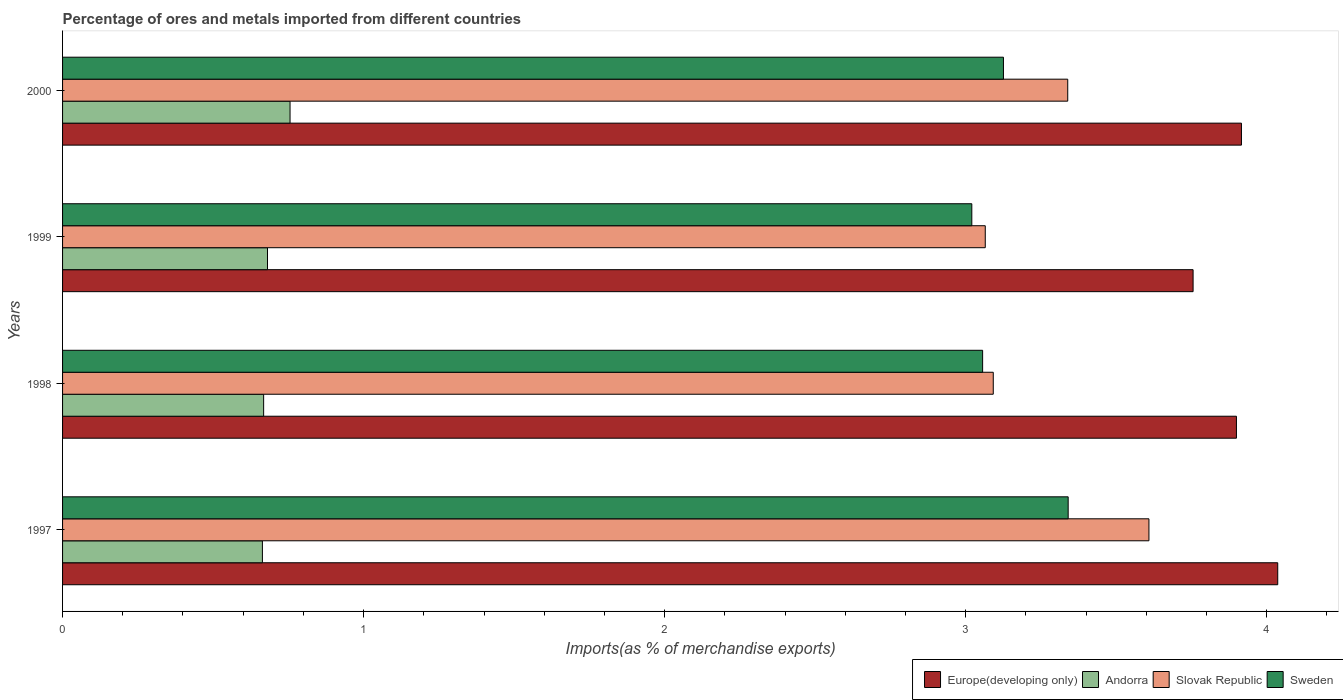How many different coloured bars are there?
Ensure brevity in your answer.  4. How many groups of bars are there?
Provide a succinct answer. 4. How many bars are there on the 1st tick from the bottom?
Provide a succinct answer. 4. What is the label of the 2nd group of bars from the top?
Offer a very short reply. 1999. What is the percentage of imports to different countries in Sweden in 2000?
Make the answer very short. 3.13. Across all years, what is the maximum percentage of imports to different countries in Sweden?
Provide a short and direct response. 3.34. Across all years, what is the minimum percentage of imports to different countries in Sweden?
Ensure brevity in your answer.  3.02. In which year was the percentage of imports to different countries in Sweden maximum?
Your answer should be compact. 1997. In which year was the percentage of imports to different countries in Europe(developing only) minimum?
Provide a succinct answer. 1999. What is the total percentage of imports to different countries in Andorra in the graph?
Make the answer very short. 2.77. What is the difference between the percentage of imports to different countries in Sweden in 1997 and that in 2000?
Your answer should be compact. 0.21. What is the difference between the percentage of imports to different countries in Slovak Republic in 2000 and the percentage of imports to different countries in Andorra in 1998?
Offer a very short reply. 2.67. What is the average percentage of imports to different countries in Europe(developing only) per year?
Make the answer very short. 3.9. In the year 2000, what is the difference between the percentage of imports to different countries in Slovak Republic and percentage of imports to different countries in Andorra?
Offer a terse response. 2.58. In how many years, is the percentage of imports to different countries in Europe(developing only) greater than 4 %?
Offer a very short reply. 1. What is the ratio of the percentage of imports to different countries in Andorra in 1997 to that in 2000?
Your response must be concise. 0.88. Is the percentage of imports to different countries in Andorra in 1998 less than that in 2000?
Your answer should be compact. Yes. Is the difference between the percentage of imports to different countries in Slovak Republic in 1998 and 2000 greater than the difference between the percentage of imports to different countries in Andorra in 1998 and 2000?
Your answer should be compact. No. What is the difference between the highest and the second highest percentage of imports to different countries in Europe(developing only)?
Your response must be concise. 0.12. What is the difference between the highest and the lowest percentage of imports to different countries in Slovak Republic?
Your response must be concise. 0.54. In how many years, is the percentage of imports to different countries in Slovak Republic greater than the average percentage of imports to different countries in Slovak Republic taken over all years?
Provide a succinct answer. 2. What does the 3rd bar from the top in 1997 represents?
Provide a succinct answer. Andorra. What does the 1st bar from the bottom in 1997 represents?
Ensure brevity in your answer.  Europe(developing only). How many years are there in the graph?
Ensure brevity in your answer.  4. Does the graph contain any zero values?
Ensure brevity in your answer.  No. Where does the legend appear in the graph?
Offer a terse response. Bottom right. How are the legend labels stacked?
Provide a short and direct response. Horizontal. What is the title of the graph?
Give a very brief answer. Percentage of ores and metals imported from different countries. Does "Cabo Verde" appear as one of the legend labels in the graph?
Provide a short and direct response. No. What is the label or title of the X-axis?
Your answer should be very brief. Imports(as % of merchandise exports). What is the Imports(as % of merchandise exports) of Europe(developing only) in 1997?
Make the answer very short. 4.04. What is the Imports(as % of merchandise exports) in Andorra in 1997?
Make the answer very short. 0.66. What is the Imports(as % of merchandise exports) of Slovak Republic in 1997?
Provide a short and direct response. 3.61. What is the Imports(as % of merchandise exports) in Sweden in 1997?
Your answer should be very brief. 3.34. What is the Imports(as % of merchandise exports) of Europe(developing only) in 1998?
Your answer should be very brief. 3.9. What is the Imports(as % of merchandise exports) of Andorra in 1998?
Make the answer very short. 0.67. What is the Imports(as % of merchandise exports) of Slovak Republic in 1998?
Your answer should be very brief. 3.09. What is the Imports(as % of merchandise exports) in Sweden in 1998?
Your response must be concise. 3.06. What is the Imports(as % of merchandise exports) in Europe(developing only) in 1999?
Offer a terse response. 3.76. What is the Imports(as % of merchandise exports) in Andorra in 1999?
Your response must be concise. 0.68. What is the Imports(as % of merchandise exports) of Slovak Republic in 1999?
Your response must be concise. 3.07. What is the Imports(as % of merchandise exports) in Sweden in 1999?
Offer a very short reply. 3.02. What is the Imports(as % of merchandise exports) in Europe(developing only) in 2000?
Offer a very short reply. 3.92. What is the Imports(as % of merchandise exports) of Andorra in 2000?
Provide a short and direct response. 0.76. What is the Imports(as % of merchandise exports) in Slovak Republic in 2000?
Your answer should be compact. 3.34. What is the Imports(as % of merchandise exports) of Sweden in 2000?
Your answer should be very brief. 3.13. Across all years, what is the maximum Imports(as % of merchandise exports) of Europe(developing only)?
Give a very brief answer. 4.04. Across all years, what is the maximum Imports(as % of merchandise exports) in Andorra?
Keep it short and to the point. 0.76. Across all years, what is the maximum Imports(as % of merchandise exports) of Slovak Republic?
Ensure brevity in your answer.  3.61. Across all years, what is the maximum Imports(as % of merchandise exports) in Sweden?
Keep it short and to the point. 3.34. Across all years, what is the minimum Imports(as % of merchandise exports) of Europe(developing only)?
Your answer should be compact. 3.76. Across all years, what is the minimum Imports(as % of merchandise exports) of Andorra?
Ensure brevity in your answer.  0.66. Across all years, what is the minimum Imports(as % of merchandise exports) in Slovak Republic?
Make the answer very short. 3.07. Across all years, what is the minimum Imports(as % of merchandise exports) of Sweden?
Your response must be concise. 3.02. What is the total Imports(as % of merchandise exports) of Europe(developing only) in the graph?
Your response must be concise. 15.61. What is the total Imports(as % of merchandise exports) in Andorra in the graph?
Offer a very short reply. 2.77. What is the total Imports(as % of merchandise exports) of Slovak Republic in the graph?
Offer a very short reply. 13.1. What is the total Imports(as % of merchandise exports) in Sweden in the graph?
Offer a terse response. 12.54. What is the difference between the Imports(as % of merchandise exports) of Europe(developing only) in 1997 and that in 1998?
Provide a short and direct response. 0.14. What is the difference between the Imports(as % of merchandise exports) in Andorra in 1997 and that in 1998?
Your answer should be very brief. -0. What is the difference between the Imports(as % of merchandise exports) of Slovak Republic in 1997 and that in 1998?
Offer a very short reply. 0.52. What is the difference between the Imports(as % of merchandise exports) of Sweden in 1997 and that in 1998?
Keep it short and to the point. 0.28. What is the difference between the Imports(as % of merchandise exports) in Europe(developing only) in 1997 and that in 1999?
Make the answer very short. 0.28. What is the difference between the Imports(as % of merchandise exports) of Andorra in 1997 and that in 1999?
Your answer should be very brief. -0.02. What is the difference between the Imports(as % of merchandise exports) of Slovak Republic in 1997 and that in 1999?
Your answer should be very brief. 0.54. What is the difference between the Imports(as % of merchandise exports) in Sweden in 1997 and that in 1999?
Give a very brief answer. 0.32. What is the difference between the Imports(as % of merchandise exports) in Europe(developing only) in 1997 and that in 2000?
Offer a very short reply. 0.12. What is the difference between the Imports(as % of merchandise exports) in Andorra in 1997 and that in 2000?
Provide a short and direct response. -0.09. What is the difference between the Imports(as % of merchandise exports) in Slovak Republic in 1997 and that in 2000?
Offer a very short reply. 0.27. What is the difference between the Imports(as % of merchandise exports) of Sweden in 1997 and that in 2000?
Provide a succinct answer. 0.21. What is the difference between the Imports(as % of merchandise exports) of Europe(developing only) in 1998 and that in 1999?
Provide a succinct answer. 0.14. What is the difference between the Imports(as % of merchandise exports) of Andorra in 1998 and that in 1999?
Keep it short and to the point. -0.01. What is the difference between the Imports(as % of merchandise exports) of Slovak Republic in 1998 and that in 1999?
Provide a succinct answer. 0.03. What is the difference between the Imports(as % of merchandise exports) of Sweden in 1998 and that in 1999?
Ensure brevity in your answer.  0.04. What is the difference between the Imports(as % of merchandise exports) in Europe(developing only) in 1998 and that in 2000?
Make the answer very short. -0.02. What is the difference between the Imports(as % of merchandise exports) of Andorra in 1998 and that in 2000?
Ensure brevity in your answer.  -0.09. What is the difference between the Imports(as % of merchandise exports) of Slovak Republic in 1998 and that in 2000?
Offer a terse response. -0.25. What is the difference between the Imports(as % of merchandise exports) of Sweden in 1998 and that in 2000?
Provide a short and direct response. -0.07. What is the difference between the Imports(as % of merchandise exports) in Europe(developing only) in 1999 and that in 2000?
Provide a short and direct response. -0.16. What is the difference between the Imports(as % of merchandise exports) in Andorra in 1999 and that in 2000?
Provide a succinct answer. -0.07. What is the difference between the Imports(as % of merchandise exports) of Slovak Republic in 1999 and that in 2000?
Give a very brief answer. -0.27. What is the difference between the Imports(as % of merchandise exports) of Sweden in 1999 and that in 2000?
Your answer should be very brief. -0.11. What is the difference between the Imports(as % of merchandise exports) of Europe(developing only) in 1997 and the Imports(as % of merchandise exports) of Andorra in 1998?
Provide a succinct answer. 3.37. What is the difference between the Imports(as % of merchandise exports) of Europe(developing only) in 1997 and the Imports(as % of merchandise exports) of Slovak Republic in 1998?
Your answer should be very brief. 0.94. What is the difference between the Imports(as % of merchandise exports) in Europe(developing only) in 1997 and the Imports(as % of merchandise exports) in Sweden in 1998?
Provide a short and direct response. 0.98. What is the difference between the Imports(as % of merchandise exports) of Andorra in 1997 and the Imports(as % of merchandise exports) of Slovak Republic in 1998?
Make the answer very short. -2.43. What is the difference between the Imports(as % of merchandise exports) in Andorra in 1997 and the Imports(as % of merchandise exports) in Sweden in 1998?
Your answer should be very brief. -2.39. What is the difference between the Imports(as % of merchandise exports) of Slovak Republic in 1997 and the Imports(as % of merchandise exports) of Sweden in 1998?
Ensure brevity in your answer.  0.55. What is the difference between the Imports(as % of merchandise exports) in Europe(developing only) in 1997 and the Imports(as % of merchandise exports) in Andorra in 1999?
Offer a very short reply. 3.36. What is the difference between the Imports(as % of merchandise exports) of Europe(developing only) in 1997 and the Imports(as % of merchandise exports) of Slovak Republic in 1999?
Your response must be concise. 0.97. What is the difference between the Imports(as % of merchandise exports) of Europe(developing only) in 1997 and the Imports(as % of merchandise exports) of Sweden in 1999?
Give a very brief answer. 1.02. What is the difference between the Imports(as % of merchandise exports) in Andorra in 1997 and the Imports(as % of merchandise exports) in Slovak Republic in 1999?
Your answer should be very brief. -2.4. What is the difference between the Imports(as % of merchandise exports) in Andorra in 1997 and the Imports(as % of merchandise exports) in Sweden in 1999?
Your response must be concise. -2.36. What is the difference between the Imports(as % of merchandise exports) of Slovak Republic in 1997 and the Imports(as % of merchandise exports) of Sweden in 1999?
Offer a terse response. 0.59. What is the difference between the Imports(as % of merchandise exports) in Europe(developing only) in 1997 and the Imports(as % of merchandise exports) in Andorra in 2000?
Your answer should be compact. 3.28. What is the difference between the Imports(as % of merchandise exports) of Europe(developing only) in 1997 and the Imports(as % of merchandise exports) of Slovak Republic in 2000?
Your response must be concise. 0.7. What is the difference between the Imports(as % of merchandise exports) in Europe(developing only) in 1997 and the Imports(as % of merchandise exports) in Sweden in 2000?
Your answer should be compact. 0.91. What is the difference between the Imports(as % of merchandise exports) in Andorra in 1997 and the Imports(as % of merchandise exports) in Slovak Republic in 2000?
Make the answer very short. -2.68. What is the difference between the Imports(as % of merchandise exports) in Andorra in 1997 and the Imports(as % of merchandise exports) in Sweden in 2000?
Provide a succinct answer. -2.46. What is the difference between the Imports(as % of merchandise exports) in Slovak Republic in 1997 and the Imports(as % of merchandise exports) in Sweden in 2000?
Ensure brevity in your answer.  0.48. What is the difference between the Imports(as % of merchandise exports) of Europe(developing only) in 1998 and the Imports(as % of merchandise exports) of Andorra in 1999?
Give a very brief answer. 3.22. What is the difference between the Imports(as % of merchandise exports) in Europe(developing only) in 1998 and the Imports(as % of merchandise exports) in Slovak Republic in 1999?
Provide a succinct answer. 0.83. What is the difference between the Imports(as % of merchandise exports) of Europe(developing only) in 1998 and the Imports(as % of merchandise exports) of Sweden in 1999?
Provide a succinct answer. 0.88. What is the difference between the Imports(as % of merchandise exports) in Andorra in 1998 and the Imports(as % of merchandise exports) in Slovak Republic in 1999?
Your response must be concise. -2.4. What is the difference between the Imports(as % of merchandise exports) in Andorra in 1998 and the Imports(as % of merchandise exports) in Sweden in 1999?
Your response must be concise. -2.35. What is the difference between the Imports(as % of merchandise exports) in Slovak Republic in 1998 and the Imports(as % of merchandise exports) in Sweden in 1999?
Make the answer very short. 0.07. What is the difference between the Imports(as % of merchandise exports) of Europe(developing only) in 1998 and the Imports(as % of merchandise exports) of Andorra in 2000?
Your answer should be very brief. 3.14. What is the difference between the Imports(as % of merchandise exports) of Europe(developing only) in 1998 and the Imports(as % of merchandise exports) of Slovak Republic in 2000?
Your answer should be compact. 0.56. What is the difference between the Imports(as % of merchandise exports) of Europe(developing only) in 1998 and the Imports(as % of merchandise exports) of Sweden in 2000?
Make the answer very short. 0.77. What is the difference between the Imports(as % of merchandise exports) of Andorra in 1998 and the Imports(as % of merchandise exports) of Slovak Republic in 2000?
Give a very brief answer. -2.67. What is the difference between the Imports(as % of merchandise exports) in Andorra in 1998 and the Imports(as % of merchandise exports) in Sweden in 2000?
Give a very brief answer. -2.46. What is the difference between the Imports(as % of merchandise exports) in Slovak Republic in 1998 and the Imports(as % of merchandise exports) in Sweden in 2000?
Your response must be concise. -0.03. What is the difference between the Imports(as % of merchandise exports) in Europe(developing only) in 1999 and the Imports(as % of merchandise exports) in Andorra in 2000?
Make the answer very short. 3. What is the difference between the Imports(as % of merchandise exports) in Europe(developing only) in 1999 and the Imports(as % of merchandise exports) in Slovak Republic in 2000?
Offer a terse response. 0.42. What is the difference between the Imports(as % of merchandise exports) of Europe(developing only) in 1999 and the Imports(as % of merchandise exports) of Sweden in 2000?
Offer a terse response. 0.63. What is the difference between the Imports(as % of merchandise exports) of Andorra in 1999 and the Imports(as % of merchandise exports) of Slovak Republic in 2000?
Your response must be concise. -2.66. What is the difference between the Imports(as % of merchandise exports) in Andorra in 1999 and the Imports(as % of merchandise exports) in Sweden in 2000?
Make the answer very short. -2.44. What is the difference between the Imports(as % of merchandise exports) of Slovak Republic in 1999 and the Imports(as % of merchandise exports) of Sweden in 2000?
Provide a short and direct response. -0.06. What is the average Imports(as % of merchandise exports) in Europe(developing only) per year?
Provide a short and direct response. 3.9. What is the average Imports(as % of merchandise exports) in Andorra per year?
Ensure brevity in your answer.  0.69. What is the average Imports(as % of merchandise exports) of Slovak Republic per year?
Your answer should be very brief. 3.28. What is the average Imports(as % of merchandise exports) in Sweden per year?
Provide a succinct answer. 3.14. In the year 1997, what is the difference between the Imports(as % of merchandise exports) in Europe(developing only) and Imports(as % of merchandise exports) in Andorra?
Keep it short and to the point. 3.37. In the year 1997, what is the difference between the Imports(as % of merchandise exports) in Europe(developing only) and Imports(as % of merchandise exports) in Slovak Republic?
Ensure brevity in your answer.  0.43. In the year 1997, what is the difference between the Imports(as % of merchandise exports) in Europe(developing only) and Imports(as % of merchandise exports) in Sweden?
Provide a succinct answer. 0.7. In the year 1997, what is the difference between the Imports(as % of merchandise exports) of Andorra and Imports(as % of merchandise exports) of Slovak Republic?
Your response must be concise. -2.94. In the year 1997, what is the difference between the Imports(as % of merchandise exports) in Andorra and Imports(as % of merchandise exports) in Sweden?
Your answer should be compact. -2.68. In the year 1997, what is the difference between the Imports(as % of merchandise exports) of Slovak Republic and Imports(as % of merchandise exports) of Sweden?
Your answer should be compact. 0.27. In the year 1998, what is the difference between the Imports(as % of merchandise exports) of Europe(developing only) and Imports(as % of merchandise exports) of Andorra?
Make the answer very short. 3.23. In the year 1998, what is the difference between the Imports(as % of merchandise exports) in Europe(developing only) and Imports(as % of merchandise exports) in Slovak Republic?
Your answer should be compact. 0.81. In the year 1998, what is the difference between the Imports(as % of merchandise exports) in Europe(developing only) and Imports(as % of merchandise exports) in Sweden?
Your answer should be compact. 0.84. In the year 1998, what is the difference between the Imports(as % of merchandise exports) of Andorra and Imports(as % of merchandise exports) of Slovak Republic?
Make the answer very short. -2.42. In the year 1998, what is the difference between the Imports(as % of merchandise exports) in Andorra and Imports(as % of merchandise exports) in Sweden?
Provide a short and direct response. -2.39. In the year 1998, what is the difference between the Imports(as % of merchandise exports) of Slovak Republic and Imports(as % of merchandise exports) of Sweden?
Your answer should be very brief. 0.04. In the year 1999, what is the difference between the Imports(as % of merchandise exports) in Europe(developing only) and Imports(as % of merchandise exports) in Andorra?
Ensure brevity in your answer.  3.07. In the year 1999, what is the difference between the Imports(as % of merchandise exports) in Europe(developing only) and Imports(as % of merchandise exports) in Slovak Republic?
Your answer should be compact. 0.69. In the year 1999, what is the difference between the Imports(as % of merchandise exports) of Europe(developing only) and Imports(as % of merchandise exports) of Sweden?
Provide a succinct answer. 0.74. In the year 1999, what is the difference between the Imports(as % of merchandise exports) of Andorra and Imports(as % of merchandise exports) of Slovak Republic?
Ensure brevity in your answer.  -2.38. In the year 1999, what is the difference between the Imports(as % of merchandise exports) of Andorra and Imports(as % of merchandise exports) of Sweden?
Provide a succinct answer. -2.34. In the year 1999, what is the difference between the Imports(as % of merchandise exports) in Slovak Republic and Imports(as % of merchandise exports) in Sweden?
Provide a short and direct response. 0.04. In the year 2000, what is the difference between the Imports(as % of merchandise exports) of Europe(developing only) and Imports(as % of merchandise exports) of Andorra?
Provide a succinct answer. 3.16. In the year 2000, what is the difference between the Imports(as % of merchandise exports) in Europe(developing only) and Imports(as % of merchandise exports) in Slovak Republic?
Your answer should be very brief. 0.58. In the year 2000, what is the difference between the Imports(as % of merchandise exports) of Europe(developing only) and Imports(as % of merchandise exports) of Sweden?
Your response must be concise. 0.79. In the year 2000, what is the difference between the Imports(as % of merchandise exports) in Andorra and Imports(as % of merchandise exports) in Slovak Republic?
Offer a terse response. -2.58. In the year 2000, what is the difference between the Imports(as % of merchandise exports) in Andorra and Imports(as % of merchandise exports) in Sweden?
Offer a very short reply. -2.37. In the year 2000, what is the difference between the Imports(as % of merchandise exports) of Slovak Republic and Imports(as % of merchandise exports) of Sweden?
Give a very brief answer. 0.21. What is the ratio of the Imports(as % of merchandise exports) in Europe(developing only) in 1997 to that in 1998?
Your answer should be compact. 1.04. What is the ratio of the Imports(as % of merchandise exports) of Slovak Republic in 1997 to that in 1998?
Your answer should be very brief. 1.17. What is the ratio of the Imports(as % of merchandise exports) of Sweden in 1997 to that in 1998?
Offer a terse response. 1.09. What is the ratio of the Imports(as % of merchandise exports) of Europe(developing only) in 1997 to that in 1999?
Offer a very short reply. 1.07. What is the ratio of the Imports(as % of merchandise exports) of Andorra in 1997 to that in 1999?
Give a very brief answer. 0.98. What is the ratio of the Imports(as % of merchandise exports) in Slovak Republic in 1997 to that in 1999?
Offer a very short reply. 1.18. What is the ratio of the Imports(as % of merchandise exports) of Sweden in 1997 to that in 1999?
Your answer should be compact. 1.11. What is the ratio of the Imports(as % of merchandise exports) of Europe(developing only) in 1997 to that in 2000?
Offer a very short reply. 1.03. What is the ratio of the Imports(as % of merchandise exports) of Andorra in 1997 to that in 2000?
Make the answer very short. 0.88. What is the ratio of the Imports(as % of merchandise exports) of Slovak Republic in 1997 to that in 2000?
Provide a succinct answer. 1.08. What is the ratio of the Imports(as % of merchandise exports) in Sweden in 1997 to that in 2000?
Keep it short and to the point. 1.07. What is the ratio of the Imports(as % of merchandise exports) of Europe(developing only) in 1998 to that in 1999?
Offer a very short reply. 1.04. What is the ratio of the Imports(as % of merchandise exports) in Andorra in 1998 to that in 1999?
Provide a short and direct response. 0.98. What is the ratio of the Imports(as % of merchandise exports) of Slovak Republic in 1998 to that in 1999?
Your answer should be very brief. 1.01. What is the ratio of the Imports(as % of merchandise exports) in Sweden in 1998 to that in 1999?
Your answer should be very brief. 1.01. What is the ratio of the Imports(as % of merchandise exports) in Europe(developing only) in 1998 to that in 2000?
Your answer should be very brief. 1. What is the ratio of the Imports(as % of merchandise exports) of Andorra in 1998 to that in 2000?
Offer a very short reply. 0.88. What is the ratio of the Imports(as % of merchandise exports) in Slovak Republic in 1998 to that in 2000?
Your answer should be very brief. 0.93. What is the ratio of the Imports(as % of merchandise exports) in Sweden in 1998 to that in 2000?
Your answer should be compact. 0.98. What is the ratio of the Imports(as % of merchandise exports) in Europe(developing only) in 1999 to that in 2000?
Keep it short and to the point. 0.96. What is the ratio of the Imports(as % of merchandise exports) of Andorra in 1999 to that in 2000?
Your answer should be very brief. 0.9. What is the ratio of the Imports(as % of merchandise exports) of Slovak Republic in 1999 to that in 2000?
Offer a very short reply. 0.92. What is the ratio of the Imports(as % of merchandise exports) of Sweden in 1999 to that in 2000?
Give a very brief answer. 0.97. What is the difference between the highest and the second highest Imports(as % of merchandise exports) of Europe(developing only)?
Your response must be concise. 0.12. What is the difference between the highest and the second highest Imports(as % of merchandise exports) of Andorra?
Your response must be concise. 0.07. What is the difference between the highest and the second highest Imports(as % of merchandise exports) of Slovak Republic?
Give a very brief answer. 0.27. What is the difference between the highest and the second highest Imports(as % of merchandise exports) in Sweden?
Offer a very short reply. 0.21. What is the difference between the highest and the lowest Imports(as % of merchandise exports) of Europe(developing only)?
Ensure brevity in your answer.  0.28. What is the difference between the highest and the lowest Imports(as % of merchandise exports) in Andorra?
Provide a succinct answer. 0.09. What is the difference between the highest and the lowest Imports(as % of merchandise exports) of Slovak Republic?
Ensure brevity in your answer.  0.54. What is the difference between the highest and the lowest Imports(as % of merchandise exports) in Sweden?
Keep it short and to the point. 0.32. 